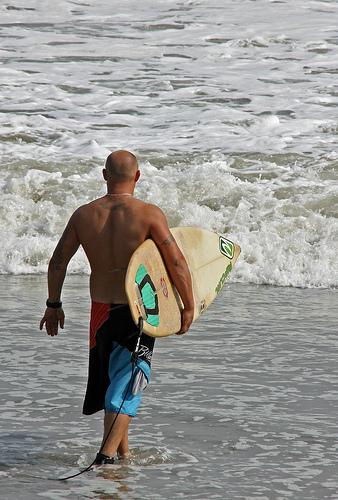Describe the image by pointing out facial and physical features of the subject and the object they are carrying. A bald, shirtless man with a tattoo on his neck and arm carries a tan-colored surfboard with green designs under his right hand while standing in the water. Provide a brief description of the image focusing on the central figure and their setting. A bald man in swim trunks carries a surfboard in the ocean, looking towards the waves and beach. Write a sentence describing the person in the image and the object they are holding. A man with no hair stands in the water wearing a necklace and a watch, holding a large surfboard with various designs in his right hand. Describe the image by mentioning the subject, the object they are carrying, and their overall appearance. A shirtless, bald man with tattoos and a necklace carries a surfboard with a sticker and green designs while standing in ocean water. Describe the image with a focus on the outfit and features of the person. A shirtless, bald man wearing black, blue, and red swim trunks with a necklace and a watch stands in the water holding a surfboard with designs. Write a short and concise description of the image. A man with a tattoo holds a surfboard while standing in the ocean wearing a watch and necklace. Write a sentence describing the main subject and their relationship with the water in the image. A man dressed in swim trunks walks towards the ocean, carrying a surfboard and looking at the calm, rolling waves. Mention the primary subject, their activity, and the surrounding environment in the image. A male surfer walks towards the ocean holding a yellow surfboard with designs, surrounded by calm water and foamy beach. Provide a description of the image stating the main subject, their appearance, and their activity. A male surfer with a bald head, tattoos, necklace, and swim trunks walks in the ocean holding a decorated surfboard, looking towards the beach. Describe the person in the image with a focus on their clothing and accessories. A bald man standing in the water wears red, black, and blue trunks, a necklace, and a black watch, holding a surfboard with designs. 